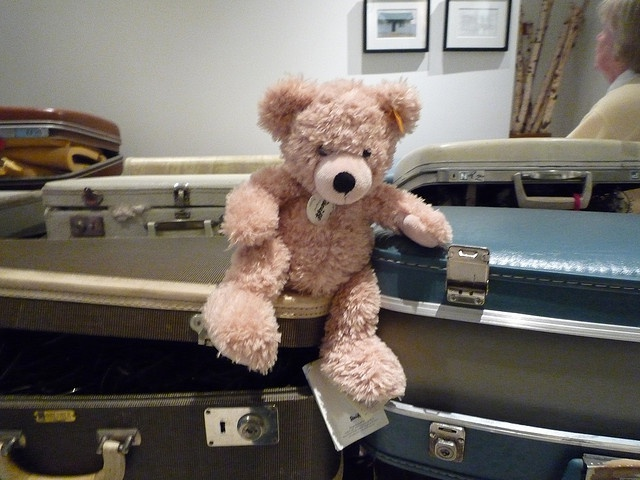Describe the objects in this image and their specific colors. I can see suitcase in gray and black tones, suitcase in gray and black tones, teddy bear in gray, tan, and lightgray tones, suitcase in gray, black, and darkgray tones, and suitcase in gray, black, darkgray, and lightgray tones in this image. 